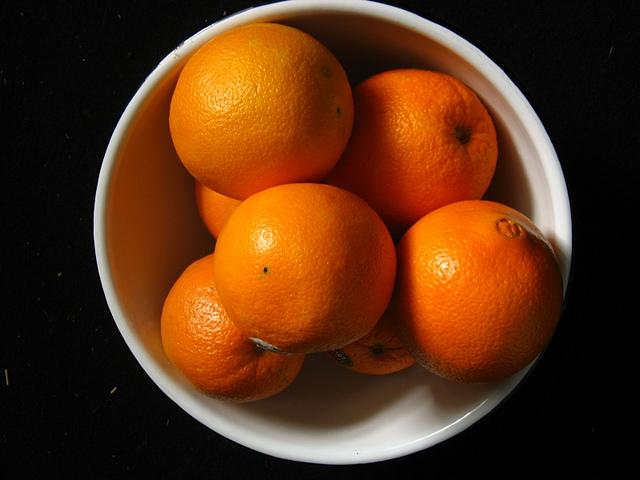How many oranges are these?
Quick response, please. 7. What type of fruit is in the bowl?
Give a very brief answer. Oranges. Is there a large color contrast in this picture?
Give a very brief answer. Yes. Is this a nice fruit bowl?
Quick response, please. Yes. What color is the bowl?
Write a very short answer. White. Are all of the fruits the same kind?
Answer briefly. Yes. How many oranges are in the picture?
Keep it brief. 7. How many fruit are in the bowl?
Quick response, please. 7. What color is the fruit?
Concise answer only. Orange. 